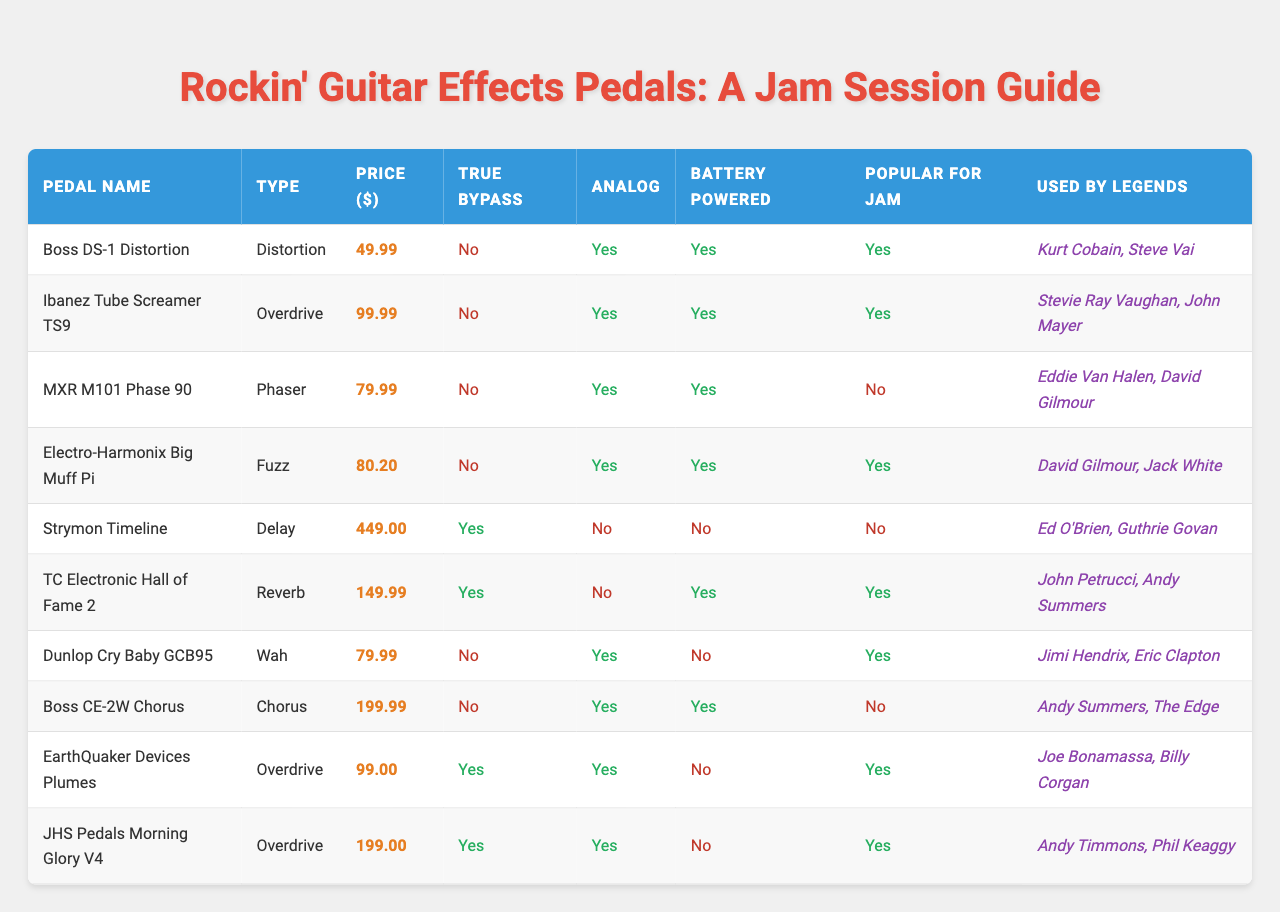What is the price of the Boss DS-1 Distortion? The table lists the price of the Boss DS-1 Distortion pedal as $49.99.
Answer: $49.99 Which pedals are used by Jimi Hendrix? The table shows that the Dunlop Cry Baby GCB95 pedal is used by Jimi Hendrix.
Answer: Dunlop Cry Baby GCB95 Are all the pedals battery powered? By reviewing the table, it is clear that not all pedals are battery powered. Notably, the Strymon Timeline and Boss CE-2W Chorus are not battery powered.
Answer: No Which type of pedal is the Ibanez Tube Screamer TS9? The table indicates that the Ibanez Tube Screamer TS9 is an Overdrive pedal.
Answer: Overdrive How much does the most expensive pedal cost? The Strymon Timeline is listed as the most expensive pedal at $449.00.
Answer: $449.00 Which pedals are popular for jam sessions? The table shows the following pedals are popular for jam sessions: Boss DS-1 Distortion, Ibanez Tube Screamer TS9, Electro-Harmonix Big Muff Pi, TC Electronic Hall of Fame 2, Dunlop Cry Baby GCB95, EarthQuaker Devices Plumes, and JHS Pedals Morning Glory V4.
Answer: 7 pedals What is the average price of the overdrive pedals listed? The prices of the overdrive pedals are Ibanez Tube Screamer TS9 ($99.99), EarthQuaker Devices Plumes ($99.00), and JHS Pedals Morning Glory V4 ($199.00). Their sum is ($99.99 + $99.00 + $199.00) = $397.99, and the average is $397.99 / 3 ≈ $132.66.
Answer: Approximately $132.66 How many pedals are used by legends who are well-known for playing rock music? From the table, it shows that 5 pedals are used by legends associated with rock music (Boss DS-1, Ibanez Tube Screamer, Dunlop Cry Baby, Electro-Harmonix Big Muff Pi, and JHS Pedals Morning Glory).
Answer: 5 pedals Is there any pedal that is both true bypass and battery powered? The TC Electronic Hall of Fame 2 and EarthQuaker Devices Plumes are both true bypass and battery powered according to the table.
Answer: Yes Which pedal with the highest price is true bypass? The Strymon Timeline is the highest priced pedal at $449.00, but it is not true bypass. The next highest priced true bypass pedal is the Boss CE-2W Chorus at $199.99.
Answer: Boss CE-2W Chorus 